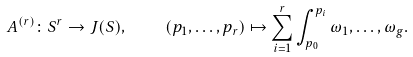<formula> <loc_0><loc_0><loc_500><loc_500>A ^ { ( r ) } \colon S ^ { r } \rightarrow J ( S ) , \quad ( p _ { 1 } , \dots , p _ { r } ) \mapsto \sum _ { i = 1 } ^ { r } \int _ { p _ { 0 } } ^ { p _ { i } } \omega _ { 1 } , \dots , \omega _ { g } .</formula> 